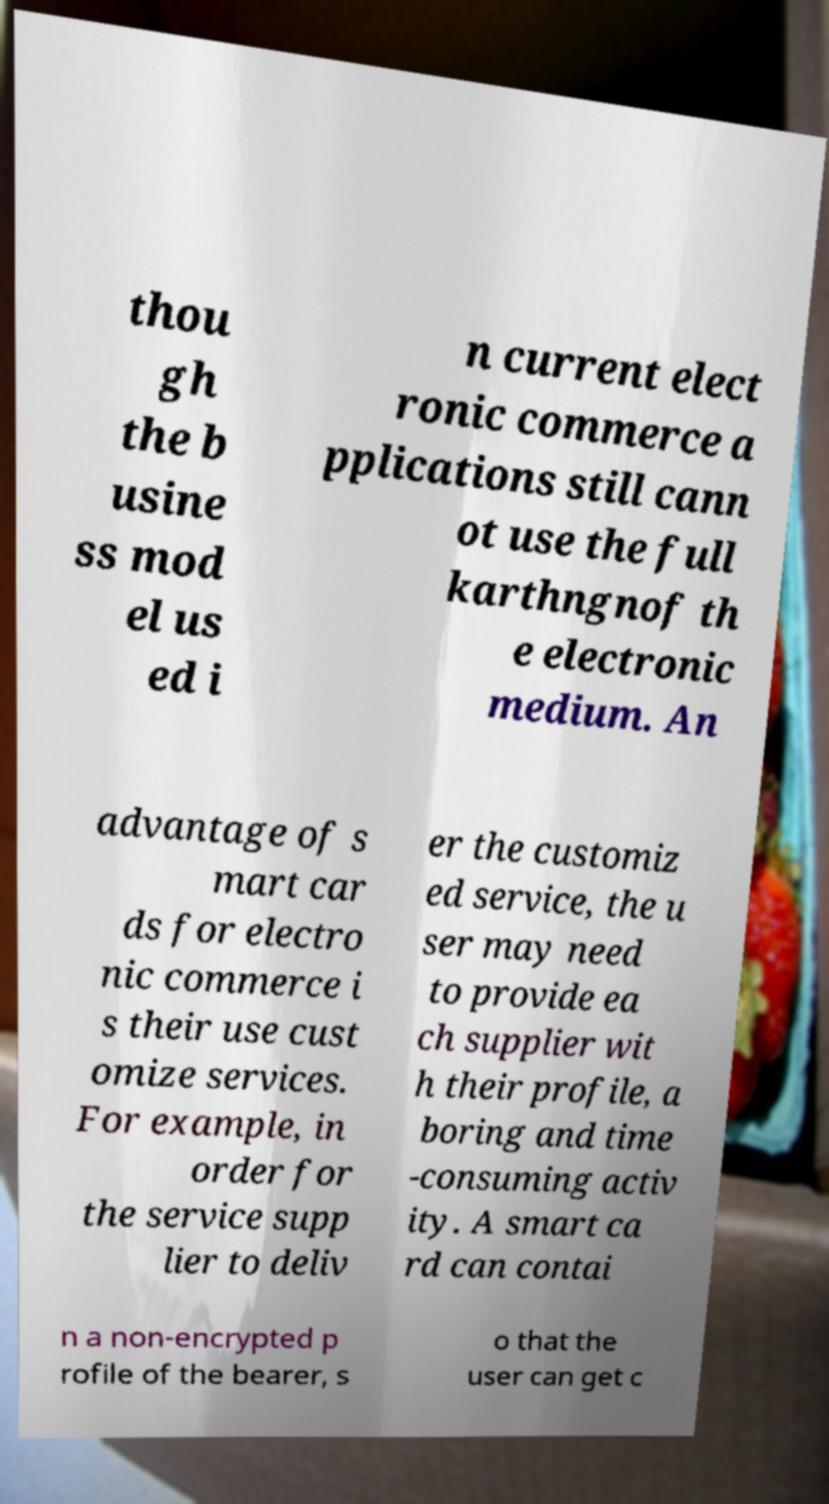Can you accurately transcribe the text from the provided image for me? thou gh the b usine ss mod el us ed i n current elect ronic commerce a pplications still cann ot use the full karthngnof th e electronic medium. An advantage of s mart car ds for electro nic commerce i s their use cust omize services. For example, in order for the service supp lier to deliv er the customiz ed service, the u ser may need to provide ea ch supplier wit h their profile, a boring and time -consuming activ ity. A smart ca rd can contai n a non-encrypted p rofile of the bearer, s o that the user can get c 